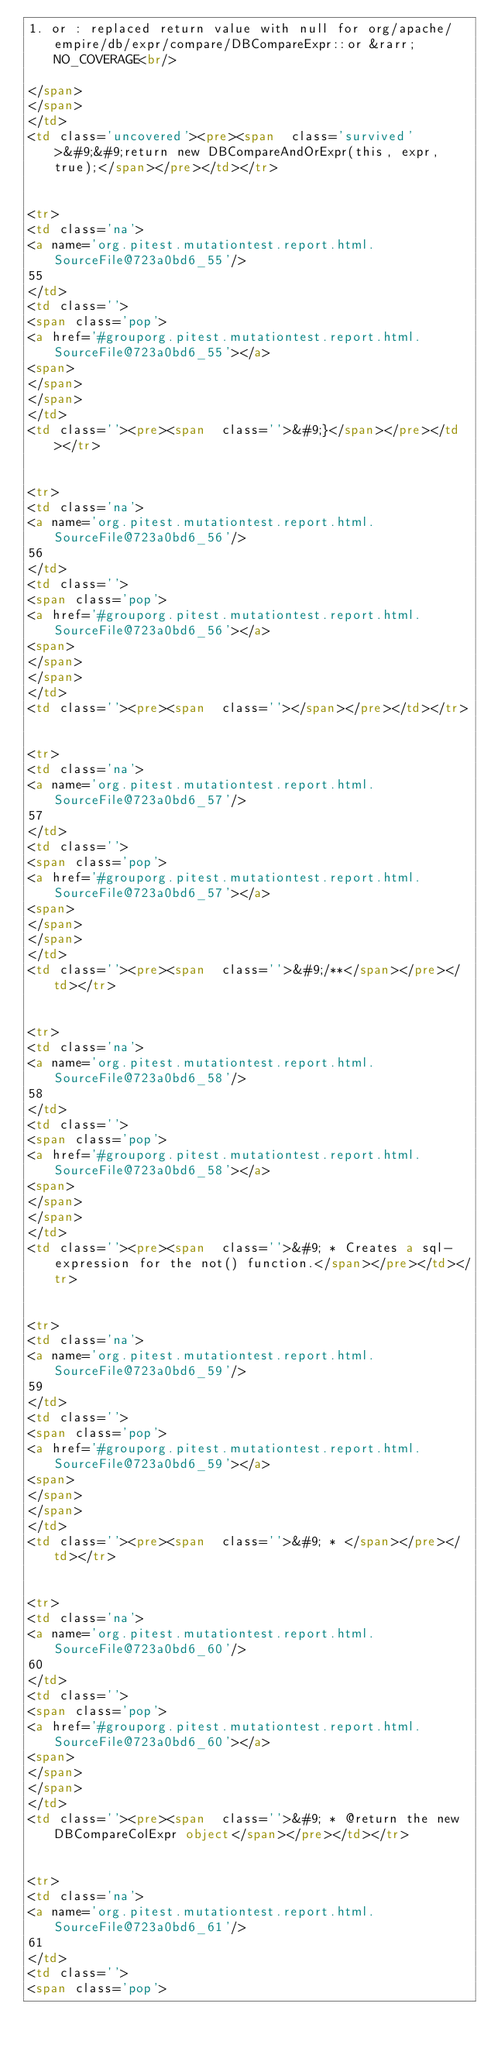<code> <loc_0><loc_0><loc_500><loc_500><_HTML_>1. or : replaced return value with null for org/apache/empire/db/expr/compare/DBCompareExpr::or &rarr; NO_COVERAGE<br/>

</span>
</span>
</td>
<td class='uncovered'><pre><span  class='survived'>&#9;&#9;return new DBCompareAndOrExpr(this, expr, true);</span></pre></td></tr>


<tr>
<td class='na'>
<a name='org.pitest.mutationtest.report.html.SourceFile@723a0bd6_55'/>
55
</td>
<td class=''>
<span class='pop'>
<a href='#grouporg.pitest.mutationtest.report.html.SourceFile@723a0bd6_55'></a>
<span>
</span>
</span>
</td>
<td class=''><pre><span  class=''>&#9;}</span></pre></td></tr>


<tr>
<td class='na'>
<a name='org.pitest.mutationtest.report.html.SourceFile@723a0bd6_56'/>
56
</td>
<td class=''>
<span class='pop'>
<a href='#grouporg.pitest.mutationtest.report.html.SourceFile@723a0bd6_56'></a>
<span>
</span>
</span>
</td>
<td class=''><pre><span  class=''></span></pre></td></tr>


<tr>
<td class='na'>
<a name='org.pitest.mutationtest.report.html.SourceFile@723a0bd6_57'/>
57
</td>
<td class=''>
<span class='pop'>
<a href='#grouporg.pitest.mutationtest.report.html.SourceFile@723a0bd6_57'></a>
<span>
</span>
</span>
</td>
<td class=''><pre><span  class=''>&#9;/**</span></pre></td></tr>


<tr>
<td class='na'>
<a name='org.pitest.mutationtest.report.html.SourceFile@723a0bd6_58'/>
58
</td>
<td class=''>
<span class='pop'>
<a href='#grouporg.pitest.mutationtest.report.html.SourceFile@723a0bd6_58'></a>
<span>
</span>
</span>
</td>
<td class=''><pre><span  class=''>&#9; * Creates a sql-expression for the not() function.</span></pre></td></tr>


<tr>
<td class='na'>
<a name='org.pitest.mutationtest.report.html.SourceFile@723a0bd6_59'/>
59
</td>
<td class=''>
<span class='pop'>
<a href='#grouporg.pitest.mutationtest.report.html.SourceFile@723a0bd6_59'></a>
<span>
</span>
</span>
</td>
<td class=''><pre><span  class=''>&#9; * </span></pre></td></tr>


<tr>
<td class='na'>
<a name='org.pitest.mutationtest.report.html.SourceFile@723a0bd6_60'/>
60
</td>
<td class=''>
<span class='pop'>
<a href='#grouporg.pitest.mutationtest.report.html.SourceFile@723a0bd6_60'></a>
<span>
</span>
</span>
</td>
<td class=''><pre><span  class=''>&#9; * @return the new DBCompareColExpr object</span></pre></td></tr>


<tr>
<td class='na'>
<a name='org.pitest.mutationtest.report.html.SourceFile@723a0bd6_61'/>
61
</td>
<td class=''>
<span class='pop'></code> 